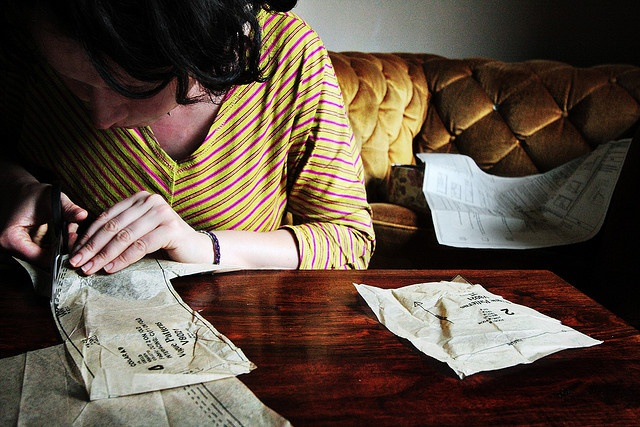Describe the objects in this image and their specific colors. I can see people in black, lightgray, and khaki tones, couch in black, maroon, lightgray, and brown tones, dining table in black, maroon, lightgray, and brown tones, and scissors in black, maroon, darkgray, and brown tones in this image. 